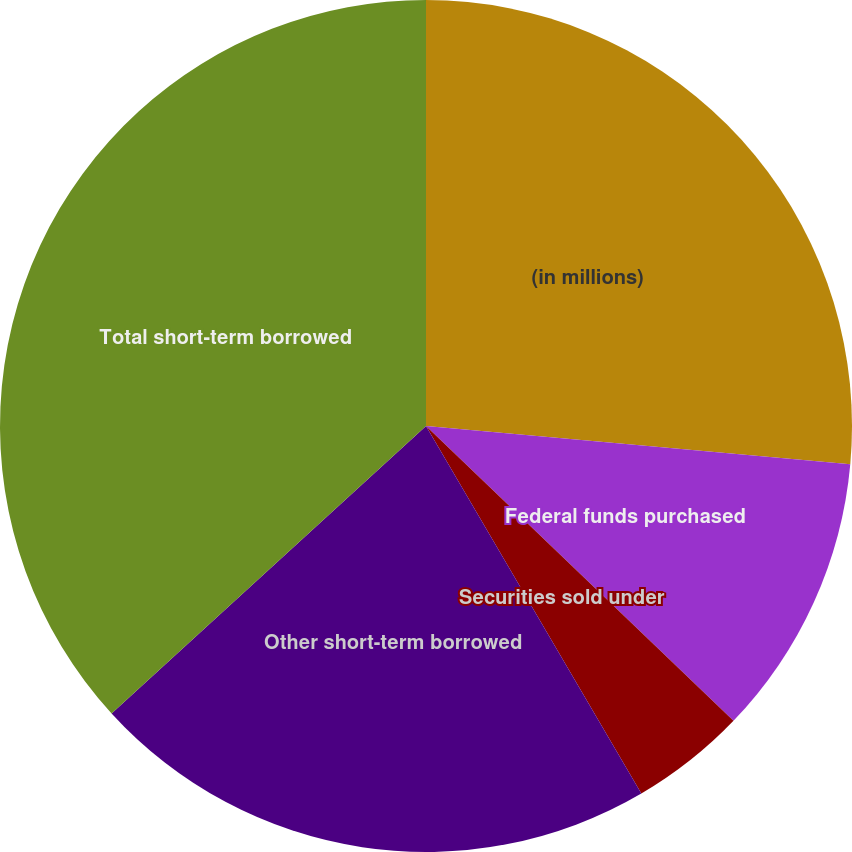Convert chart to OTSL. <chart><loc_0><loc_0><loc_500><loc_500><pie_chart><fcel>(in millions)<fcel>Federal funds purchased<fcel>Securities sold under<fcel>Other short-term borrowed<fcel>Total short-term borrowed<nl><fcel>26.43%<fcel>10.74%<fcel>4.4%<fcel>21.65%<fcel>36.79%<nl></chart> 